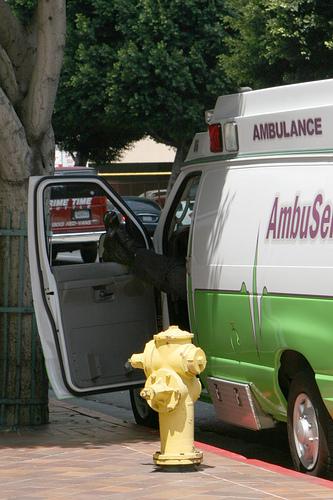Why is this vehicle allowed to park near the fire hydrant?
Be succinct. Ambulance. What color is the hydrant?
Short answer required. Yellow. Does the ambulance have its emergency lights on?
Write a very short answer. No. What is the name of the car?
Short answer required. Ambulance. What language is written?
Quick response, please. English. Is one of the car's door open?
Short answer required. Yes. Who is driving the ambulance?
Answer briefly. No one. Do you see a taxi cab?
Be succinct. No. What color is the fire hydrant?
Be succinct. Yellow. Is this a parking meter?
Short answer required. No. Where is the fire hydrant?
Be succinct. Sidewalk. 